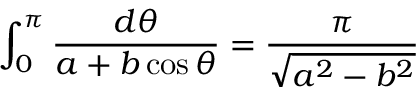<formula> <loc_0><loc_0><loc_500><loc_500>\int _ { 0 } ^ { \pi } \frac { d \theta } { a + b \cos \theta } = \frac { \pi } { \sqrt { a ^ { 2 } - b ^ { 2 } } }</formula> 